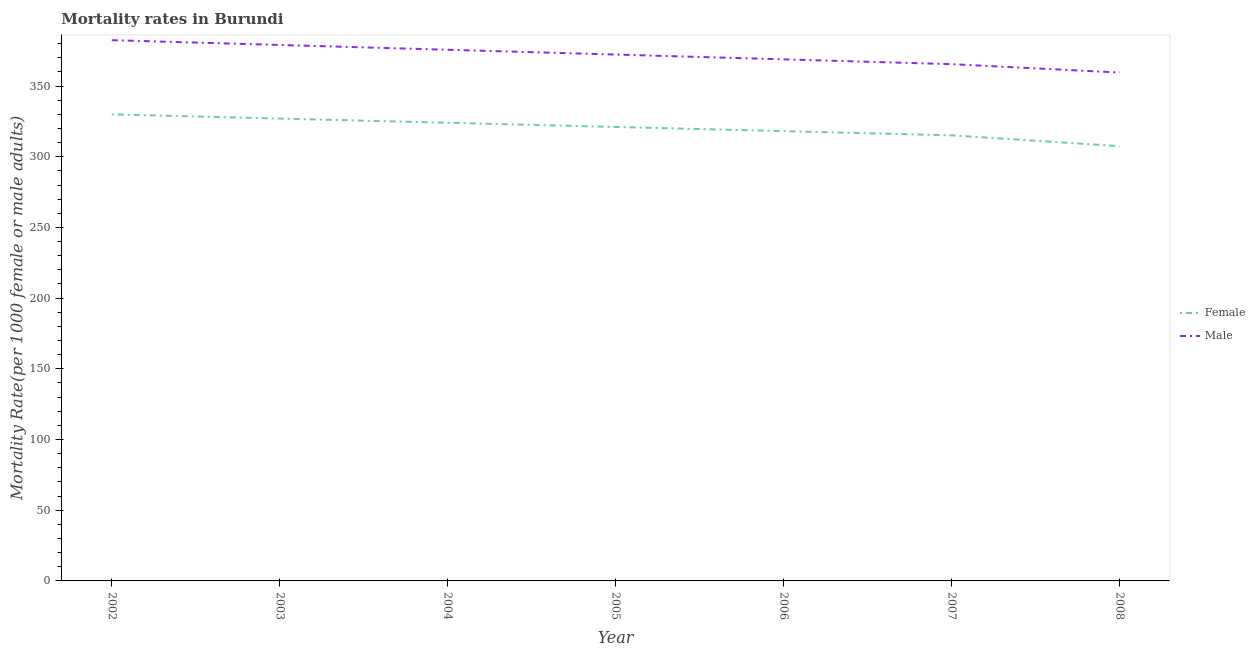How many different coloured lines are there?
Keep it short and to the point. 2. What is the male mortality rate in 2006?
Provide a short and direct response. 368.88. Across all years, what is the maximum male mortality rate?
Offer a terse response. 382.45. Across all years, what is the minimum female mortality rate?
Your answer should be compact. 307.51. What is the total male mortality rate in the graph?
Ensure brevity in your answer.  2603.33. What is the difference between the female mortality rate in 2005 and that in 2008?
Your answer should be compact. 13.56. What is the difference between the male mortality rate in 2003 and the female mortality rate in 2005?
Your answer should be compact. 57.99. What is the average male mortality rate per year?
Keep it short and to the point. 371.9. In the year 2004, what is the difference between the female mortality rate and male mortality rate?
Keep it short and to the point. -51.63. What is the ratio of the male mortality rate in 2003 to that in 2004?
Offer a very short reply. 1.01. What is the difference between the highest and the second highest female mortality rate?
Your response must be concise. 2.97. What is the difference between the highest and the lowest male mortality rate?
Provide a short and direct response. 22.9. Is the female mortality rate strictly greater than the male mortality rate over the years?
Offer a very short reply. No. How many lines are there?
Your answer should be compact. 2. Does the graph contain any zero values?
Your response must be concise. No. Where does the legend appear in the graph?
Your answer should be very brief. Center right. How are the legend labels stacked?
Your answer should be compact. Vertical. What is the title of the graph?
Provide a short and direct response. Mortality rates in Burundi. Does "Urban" appear as one of the legend labels in the graph?
Provide a succinct answer. No. What is the label or title of the X-axis?
Ensure brevity in your answer.  Year. What is the label or title of the Y-axis?
Provide a short and direct response. Mortality Rate(per 1000 female or male adults). What is the Mortality Rate(per 1000 female or male adults) in Female in 2002?
Offer a terse response. 329.97. What is the Mortality Rate(per 1000 female or male adults) in Male in 2002?
Provide a succinct answer. 382.45. What is the Mortality Rate(per 1000 female or male adults) of Female in 2003?
Provide a short and direct response. 327. What is the Mortality Rate(per 1000 female or male adults) in Male in 2003?
Keep it short and to the point. 379.05. What is the Mortality Rate(per 1000 female or male adults) in Female in 2004?
Provide a short and direct response. 324.03. What is the Mortality Rate(per 1000 female or male adults) in Male in 2004?
Provide a succinct answer. 375.66. What is the Mortality Rate(per 1000 female or male adults) of Female in 2005?
Offer a terse response. 321.07. What is the Mortality Rate(per 1000 female or male adults) of Male in 2005?
Keep it short and to the point. 372.27. What is the Mortality Rate(per 1000 female or male adults) in Female in 2006?
Your response must be concise. 318.1. What is the Mortality Rate(per 1000 female or male adults) of Male in 2006?
Your response must be concise. 368.88. What is the Mortality Rate(per 1000 female or male adults) in Female in 2007?
Provide a succinct answer. 315.14. What is the Mortality Rate(per 1000 female or male adults) of Male in 2007?
Provide a short and direct response. 365.48. What is the Mortality Rate(per 1000 female or male adults) in Female in 2008?
Make the answer very short. 307.51. What is the Mortality Rate(per 1000 female or male adults) of Male in 2008?
Your answer should be very brief. 359.54. Across all years, what is the maximum Mortality Rate(per 1000 female or male adults) in Female?
Make the answer very short. 329.97. Across all years, what is the maximum Mortality Rate(per 1000 female or male adults) in Male?
Offer a very short reply. 382.45. Across all years, what is the minimum Mortality Rate(per 1000 female or male adults) of Female?
Offer a very short reply. 307.51. Across all years, what is the minimum Mortality Rate(per 1000 female or male adults) of Male?
Provide a succinct answer. 359.54. What is the total Mortality Rate(per 1000 female or male adults) of Female in the graph?
Your response must be concise. 2242.82. What is the total Mortality Rate(per 1000 female or male adults) of Male in the graph?
Your answer should be compact. 2603.33. What is the difference between the Mortality Rate(per 1000 female or male adults) in Female in 2002 and that in 2003?
Provide a succinct answer. 2.97. What is the difference between the Mortality Rate(per 1000 female or male adults) of Male in 2002 and that in 2003?
Your answer should be compact. 3.39. What is the difference between the Mortality Rate(per 1000 female or male adults) of Female in 2002 and that in 2004?
Provide a short and direct response. 5.93. What is the difference between the Mortality Rate(per 1000 female or male adults) in Male in 2002 and that in 2004?
Provide a succinct answer. 6.79. What is the difference between the Mortality Rate(per 1000 female or male adults) in Female in 2002 and that in 2005?
Make the answer very short. 8.9. What is the difference between the Mortality Rate(per 1000 female or male adults) in Male in 2002 and that in 2005?
Provide a short and direct response. 10.18. What is the difference between the Mortality Rate(per 1000 female or male adults) in Female in 2002 and that in 2006?
Keep it short and to the point. 11.86. What is the difference between the Mortality Rate(per 1000 female or male adults) in Male in 2002 and that in 2006?
Keep it short and to the point. 13.57. What is the difference between the Mortality Rate(per 1000 female or male adults) in Female in 2002 and that in 2007?
Your answer should be very brief. 14.83. What is the difference between the Mortality Rate(per 1000 female or male adults) of Male in 2002 and that in 2007?
Your response must be concise. 16.96. What is the difference between the Mortality Rate(per 1000 female or male adults) in Female in 2002 and that in 2008?
Offer a terse response. 22.45. What is the difference between the Mortality Rate(per 1000 female or male adults) of Male in 2002 and that in 2008?
Your response must be concise. 22.9. What is the difference between the Mortality Rate(per 1000 female or male adults) in Female in 2003 and that in 2004?
Your response must be concise. 2.97. What is the difference between the Mortality Rate(per 1000 female or male adults) in Male in 2003 and that in 2004?
Your answer should be compact. 3.39. What is the difference between the Mortality Rate(per 1000 female or male adults) of Female in 2003 and that in 2005?
Your answer should be very brief. 5.93. What is the difference between the Mortality Rate(per 1000 female or male adults) of Male in 2003 and that in 2005?
Ensure brevity in your answer.  6.79. What is the difference between the Mortality Rate(per 1000 female or male adults) in Female in 2003 and that in 2006?
Provide a short and direct response. 8.9. What is the difference between the Mortality Rate(per 1000 female or male adults) of Male in 2003 and that in 2006?
Keep it short and to the point. 10.18. What is the difference between the Mortality Rate(per 1000 female or male adults) in Female in 2003 and that in 2007?
Provide a short and direct response. 11.86. What is the difference between the Mortality Rate(per 1000 female or male adults) of Male in 2003 and that in 2007?
Offer a very short reply. 13.57. What is the difference between the Mortality Rate(per 1000 female or male adults) in Female in 2003 and that in 2008?
Offer a very short reply. 19.49. What is the difference between the Mortality Rate(per 1000 female or male adults) in Male in 2003 and that in 2008?
Your response must be concise. 19.51. What is the difference between the Mortality Rate(per 1000 female or male adults) in Female in 2004 and that in 2005?
Keep it short and to the point. 2.97. What is the difference between the Mortality Rate(per 1000 female or male adults) of Male in 2004 and that in 2005?
Your response must be concise. 3.39. What is the difference between the Mortality Rate(per 1000 female or male adults) in Female in 2004 and that in 2006?
Offer a terse response. 5.93. What is the difference between the Mortality Rate(per 1000 female or male adults) of Male in 2004 and that in 2006?
Provide a succinct answer. 6.79. What is the difference between the Mortality Rate(per 1000 female or male adults) in Female in 2004 and that in 2007?
Ensure brevity in your answer.  8.9. What is the difference between the Mortality Rate(per 1000 female or male adults) in Male in 2004 and that in 2007?
Keep it short and to the point. 10.18. What is the difference between the Mortality Rate(per 1000 female or male adults) in Female in 2004 and that in 2008?
Ensure brevity in your answer.  16.52. What is the difference between the Mortality Rate(per 1000 female or male adults) of Male in 2004 and that in 2008?
Offer a terse response. 16.12. What is the difference between the Mortality Rate(per 1000 female or male adults) in Female in 2005 and that in 2006?
Provide a short and direct response. 2.96. What is the difference between the Mortality Rate(per 1000 female or male adults) in Male in 2005 and that in 2006?
Give a very brief answer. 3.39. What is the difference between the Mortality Rate(per 1000 female or male adults) of Female in 2005 and that in 2007?
Provide a succinct answer. 5.93. What is the difference between the Mortality Rate(per 1000 female or male adults) in Male in 2005 and that in 2007?
Make the answer very short. 6.79. What is the difference between the Mortality Rate(per 1000 female or male adults) in Female in 2005 and that in 2008?
Offer a very short reply. 13.56. What is the difference between the Mortality Rate(per 1000 female or male adults) in Male in 2005 and that in 2008?
Your answer should be compact. 12.72. What is the difference between the Mortality Rate(per 1000 female or male adults) in Female in 2006 and that in 2007?
Provide a short and direct response. 2.97. What is the difference between the Mortality Rate(per 1000 female or male adults) in Male in 2006 and that in 2007?
Ensure brevity in your answer.  3.39. What is the difference between the Mortality Rate(per 1000 female or male adults) in Female in 2006 and that in 2008?
Your response must be concise. 10.59. What is the difference between the Mortality Rate(per 1000 female or male adults) of Male in 2006 and that in 2008?
Your answer should be very brief. 9.33. What is the difference between the Mortality Rate(per 1000 female or male adults) of Female in 2007 and that in 2008?
Your answer should be compact. 7.63. What is the difference between the Mortality Rate(per 1000 female or male adults) of Male in 2007 and that in 2008?
Provide a short and direct response. 5.94. What is the difference between the Mortality Rate(per 1000 female or male adults) of Female in 2002 and the Mortality Rate(per 1000 female or male adults) of Male in 2003?
Ensure brevity in your answer.  -49.09. What is the difference between the Mortality Rate(per 1000 female or male adults) in Female in 2002 and the Mortality Rate(per 1000 female or male adults) in Male in 2004?
Your answer should be very brief. -45.7. What is the difference between the Mortality Rate(per 1000 female or male adults) in Female in 2002 and the Mortality Rate(per 1000 female or male adults) in Male in 2005?
Provide a succinct answer. -42.3. What is the difference between the Mortality Rate(per 1000 female or male adults) in Female in 2002 and the Mortality Rate(per 1000 female or male adults) in Male in 2006?
Your answer should be compact. -38.91. What is the difference between the Mortality Rate(per 1000 female or male adults) in Female in 2002 and the Mortality Rate(per 1000 female or male adults) in Male in 2007?
Provide a succinct answer. -35.52. What is the difference between the Mortality Rate(per 1000 female or male adults) of Female in 2002 and the Mortality Rate(per 1000 female or male adults) of Male in 2008?
Offer a very short reply. -29.58. What is the difference between the Mortality Rate(per 1000 female or male adults) of Female in 2003 and the Mortality Rate(per 1000 female or male adults) of Male in 2004?
Provide a short and direct response. -48.66. What is the difference between the Mortality Rate(per 1000 female or male adults) in Female in 2003 and the Mortality Rate(per 1000 female or male adults) in Male in 2005?
Provide a succinct answer. -45.27. What is the difference between the Mortality Rate(per 1000 female or male adults) in Female in 2003 and the Mortality Rate(per 1000 female or male adults) in Male in 2006?
Offer a terse response. -41.88. What is the difference between the Mortality Rate(per 1000 female or male adults) of Female in 2003 and the Mortality Rate(per 1000 female or male adults) of Male in 2007?
Your answer should be compact. -38.48. What is the difference between the Mortality Rate(per 1000 female or male adults) in Female in 2003 and the Mortality Rate(per 1000 female or male adults) in Male in 2008?
Make the answer very short. -32.54. What is the difference between the Mortality Rate(per 1000 female or male adults) in Female in 2004 and the Mortality Rate(per 1000 female or male adults) in Male in 2005?
Give a very brief answer. -48.23. What is the difference between the Mortality Rate(per 1000 female or male adults) of Female in 2004 and the Mortality Rate(per 1000 female or male adults) of Male in 2006?
Provide a short and direct response. -44.84. What is the difference between the Mortality Rate(per 1000 female or male adults) in Female in 2004 and the Mortality Rate(per 1000 female or male adults) in Male in 2007?
Keep it short and to the point. -41.45. What is the difference between the Mortality Rate(per 1000 female or male adults) in Female in 2004 and the Mortality Rate(per 1000 female or male adults) in Male in 2008?
Make the answer very short. -35.51. What is the difference between the Mortality Rate(per 1000 female or male adults) in Female in 2005 and the Mortality Rate(per 1000 female or male adults) in Male in 2006?
Your response must be concise. -47.81. What is the difference between the Mortality Rate(per 1000 female or male adults) in Female in 2005 and the Mortality Rate(per 1000 female or male adults) in Male in 2007?
Your answer should be very brief. -44.41. What is the difference between the Mortality Rate(per 1000 female or male adults) of Female in 2005 and the Mortality Rate(per 1000 female or male adults) of Male in 2008?
Your answer should be compact. -38.48. What is the difference between the Mortality Rate(per 1000 female or male adults) of Female in 2006 and the Mortality Rate(per 1000 female or male adults) of Male in 2007?
Provide a succinct answer. -47.38. What is the difference between the Mortality Rate(per 1000 female or male adults) in Female in 2006 and the Mortality Rate(per 1000 female or male adults) in Male in 2008?
Your answer should be very brief. -41.44. What is the difference between the Mortality Rate(per 1000 female or male adults) of Female in 2007 and the Mortality Rate(per 1000 female or male adults) of Male in 2008?
Your response must be concise. -44.41. What is the average Mortality Rate(per 1000 female or male adults) in Female per year?
Give a very brief answer. 320.4. What is the average Mortality Rate(per 1000 female or male adults) of Male per year?
Ensure brevity in your answer.  371.9. In the year 2002, what is the difference between the Mortality Rate(per 1000 female or male adults) of Female and Mortality Rate(per 1000 female or male adults) of Male?
Provide a succinct answer. -52.48. In the year 2003, what is the difference between the Mortality Rate(per 1000 female or male adults) in Female and Mortality Rate(per 1000 female or male adults) in Male?
Give a very brief answer. -52.05. In the year 2004, what is the difference between the Mortality Rate(per 1000 female or male adults) in Female and Mortality Rate(per 1000 female or male adults) in Male?
Make the answer very short. -51.63. In the year 2005, what is the difference between the Mortality Rate(per 1000 female or male adults) of Female and Mortality Rate(per 1000 female or male adults) of Male?
Give a very brief answer. -51.2. In the year 2006, what is the difference between the Mortality Rate(per 1000 female or male adults) of Female and Mortality Rate(per 1000 female or male adults) of Male?
Provide a short and direct response. -50.77. In the year 2007, what is the difference between the Mortality Rate(per 1000 female or male adults) of Female and Mortality Rate(per 1000 female or male adults) of Male?
Provide a short and direct response. -50.34. In the year 2008, what is the difference between the Mortality Rate(per 1000 female or male adults) in Female and Mortality Rate(per 1000 female or male adults) in Male?
Offer a terse response. -52.03. What is the ratio of the Mortality Rate(per 1000 female or male adults) in Female in 2002 to that in 2003?
Provide a succinct answer. 1.01. What is the ratio of the Mortality Rate(per 1000 female or male adults) in Female in 2002 to that in 2004?
Your response must be concise. 1.02. What is the ratio of the Mortality Rate(per 1000 female or male adults) of Male in 2002 to that in 2004?
Provide a short and direct response. 1.02. What is the ratio of the Mortality Rate(per 1000 female or male adults) of Female in 2002 to that in 2005?
Your answer should be very brief. 1.03. What is the ratio of the Mortality Rate(per 1000 female or male adults) of Male in 2002 to that in 2005?
Provide a short and direct response. 1.03. What is the ratio of the Mortality Rate(per 1000 female or male adults) of Female in 2002 to that in 2006?
Provide a short and direct response. 1.04. What is the ratio of the Mortality Rate(per 1000 female or male adults) in Male in 2002 to that in 2006?
Ensure brevity in your answer.  1.04. What is the ratio of the Mortality Rate(per 1000 female or male adults) of Female in 2002 to that in 2007?
Offer a terse response. 1.05. What is the ratio of the Mortality Rate(per 1000 female or male adults) in Male in 2002 to that in 2007?
Your answer should be very brief. 1.05. What is the ratio of the Mortality Rate(per 1000 female or male adults) of Female in 2002 to that in 2008?
Offer a very short reply. 1.07. What is the ratio of the Mortality Rate(per 1000 female or male adults) of Male in 2002 to that in 2008?
Provide a succinct answer. 1.06. What is the ratio of the Mortality Rate(per 1000 female or male adults) in Female in 2003 to that in 2004?
Make the answer very short. 1.01. What is the ratio of the Mortality Rate(per 1000 female or male adults) of Female in 2003 to that in 2005?
Offer a terse response. 1.02. What is the ratio of the Mortality Rate(per 1000 female or male adults) of Male in 2003 to that in 2005?
Ensure brevity in your answer.  1.02. What is the ratio of the Mortality Rate(per 1000 female or male adults) of Female in 2003 to that in 2006?
Provide a short and direct response. 1.03. What is the ratio of the Mortality Rate(per 1000 female or male adults) of Male in 2003 to that in 2006?
Make the answer very short. 1.03. What is the ratio of the Mortality Rate(per 1000 female or male adults) in Female in 2003 to that in 2007?
Your response must be concise. 1.04. What is the ratio of the Mortality Rate(per 1000 female or male adults) of Male in 2003 to that in 2007?
Your answer should be very brief. 1.04. What is the ratio of the Mortality Rate(per 1000 female or male adults) of Female in 2003 to that in 2008?
Give a very brief answer. 1.06. What is the ratio of the Mortality Rate(per 1000 female or male adults) in Male in 2003 to that in 2008?
Your response must be concise. 1.05. What is the ratio of the Mortality Rate(per 1000 female or male adults) of Female in 2004 to that in 2005?
Ensure brevity in your answer.  1.01. What is the ratio of the Mortality Rate(per 1000 female or male adults) in Male in 2004 to that in 2005?
Your answer should be compact. 1.01. What is the ratio of the Mortality Rate(per 1000 female or male adults) of Female in 2004 to that in 2006?
Keep it short and to the point. 1.02. What is the ratio of the Mortality Rate(per 1000 female or male adults) of Male in 2004 to that in 2006?
Offer a very short reply. 1.02. What is the ratio of the Mortality Rate(per 1000 female or male adults) of Female in 2004 to that in 2007?
Give a very brief answer. 1.03. What is the ratio of the Mortality Rate(per 1000 female or male adults) of Male in 2004 to that in 2007?
Ensure brevity in your answer.  1.03. What is the ratio of the Mortality Rate(per 1000 female or male adults) of Female in 2004 to that in 2008?
Make the answer very short. 1.05. What is the ratio of the Mortality Rate(per 1000 female or male adults) of Male in 2004 to that in 2008?
Provide a succinct answer. 1.04. What is the ratio of the Mortality Rate(per 1000 female or male adults) of Female in 2005 to that in 2006?
Offer a very short reply. 1.01. What is the ratio of the Mortality Rate(per 1000 female or male adults) of Male in 2005 to that in 2006?
Provide a short and direct response. 1.01. What is the ratio of the Mortality Rate(per 1000 female or male adults) in Female in 2005 to that in 2007?
Offer a terse response. 1.02. What is the ratio of the Mortality Rate(per 1000 female or male adults) of Male in 2005 to that in 2007?
Give a very brief answer. 1.02. What is the ratio of the Mortality Rate(per 1000 female or male adults) of Female in 2005 to that in 2008?
Keep it short and to the point. 1.04. What is the ratio of the Mortality Rate(per 1000 female or male adults) in Male in 2005 to that in 2008?
Your answer should be very brief. 1.04. What is the ratio of the Mortality Rate(per 1000 female or male adults) in Female in 2006 to that in 2007?
Make the answer very short. 1.01. What is the ratio of the Mortality Rate(per 1000 female or male adults) in Male in 2006 to that in 2007?
Give a very brief answer. 1.01. What is the ratio of the Mortality Rate(per 1000 female or male adults) in Female in 2006 to that in 2008?
Offer a terse response. 1.03. What is the ratio of the Mortality Rate(per 1000 female or male adults) of Male in 2006 to that in 2008?
Provide a short and direct response. 1.03. What is the ratio of the Mortality Rate(per 1000 female or male adults) in Female in 2007 to that in 2008?
Your response must be concise. 1.02. What is the ratio of the Mortality Rate(per 1000 female or male adults) in Male in 2007 to that in 2008?
Make the answer very short. 1.02. What is the difference between the highest and the second highest Mortality Rate(per 1000 female or male adults) of Female?
Keep it short and to the point. 2.97. What is the difference between the highest and the second highest Mortality Rate(per 1000 female or male adults) of Male?
Keep it short and to the point. 3.39. What is the difference between the highest and the lowest Mortality Rate(per 1000 female or male adults) in Female?
Ensure brevity in your answer.  22.45. What is the difference between the highest and the lowest Mortality Rate(per 1000 female or male adults) of Male?
Ensure brevity in your answer.  22.9. 